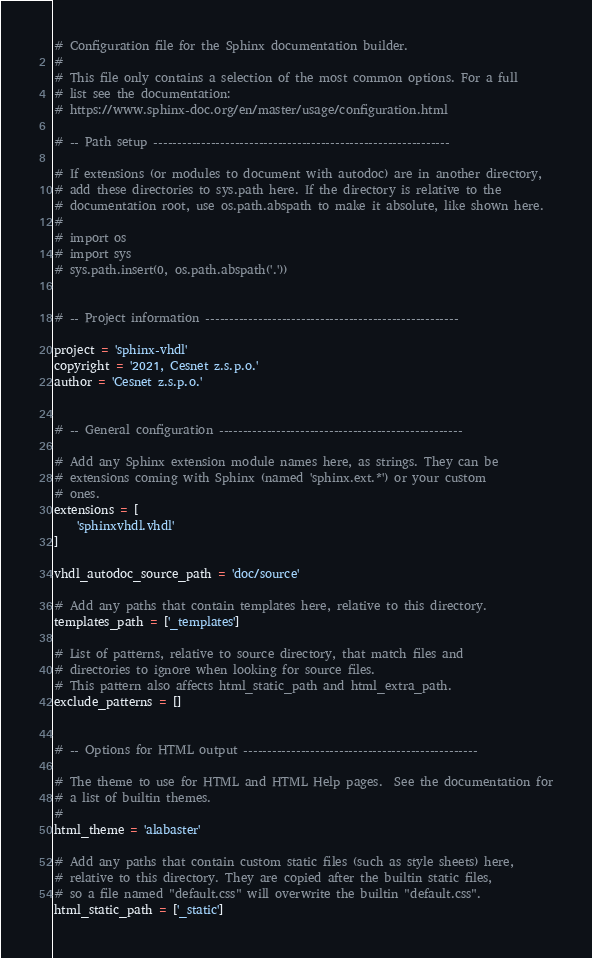Convert code to text. <code><loc_0><loc_0><loc_500><loc_500><_Python_># Configuration file for the Sphinx documentation builder.
#
# This file only contains a selection of the most common options. For a full
# list see the documentation:
# https://www.sphinx-doc.org/en/master/usage/configuration.html

# -- Path setup --------------------------------------------------------------

# If extensions (or modules to document with autodoc) are in another directory,
# add these directories to sys.path here. If the directory is relative to the
# documentation root, use os.path.abspath to make it absolute, like shown here.
#
# import os
# import sys
# sys.path.insert(0, os.path.abspath('.'))


# -- Project information -----------------------------------------------------

project = 'sphinx-vhdl'
copyright = '2021, Cesnet z.s.p.o.'
author = 'Cesnet z.s.p.o.'


# -- General configuration ---------------------------------------------------

# Add any Sphinx extension module names here, as strings. They can be
# extensions coming with Sphinx (named 'sphinx.ext.*') or your custom
# ones.
extensions = [
    'sphinxvhdl.vhdl'
]

vhdl_autodoc_source_path = 'doc/source'

# Add any paths that contain templates here, relative to this directory.
templates_path = ['_templates']

# List of patterns, relative to source directory, that match files and
# directories to ignore when looking for source files.
# This pattern also affects html_static_path and html_extra_path.
exclude_patterns = []


# -- Options for HTML output -------------------------------------------------

# The theme to use for HTML and HTML Help pages.  See the documentation for
# a list of builtin themes.
#
html_theme = 'alabaster'

# Add any paths that contain custom static files (such as style sheets) here,
# relative to this directory. They are copied after the builtin static files,
# so a file named "default.css" will overwrite the builtin "default.css".
html_static_path = ['_static']</code> 